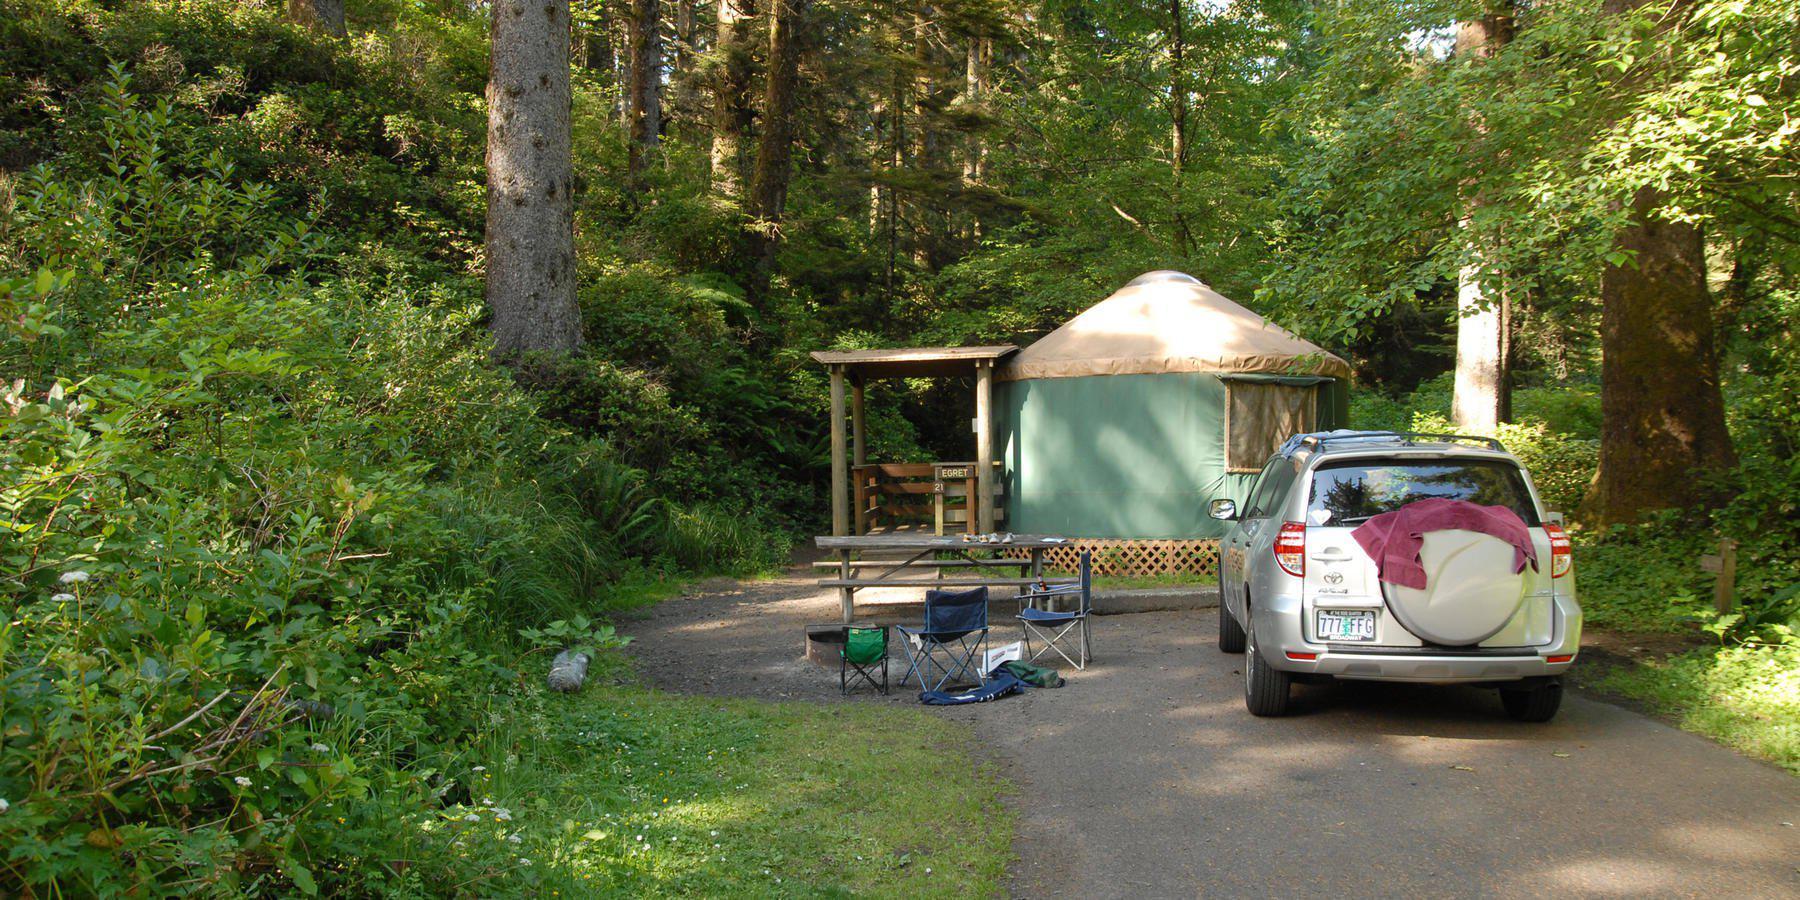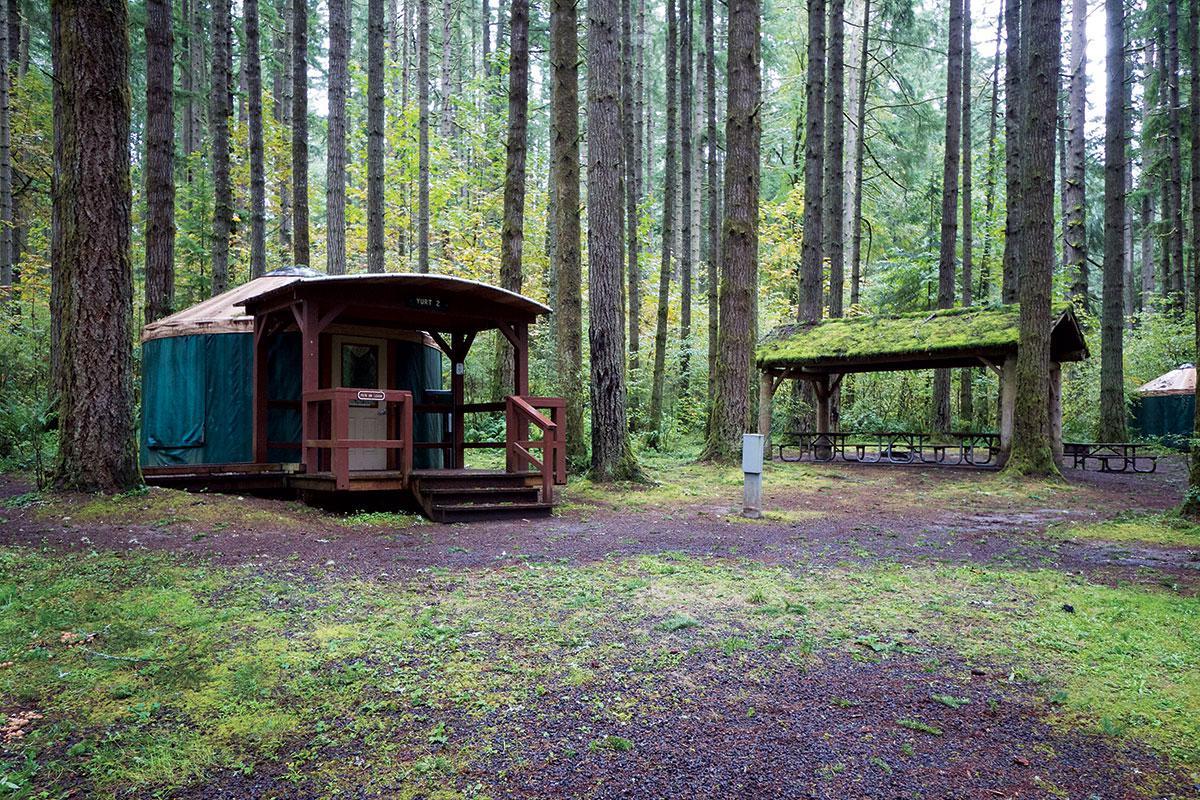The first image is the image on the left, the second image is the image on the right. Considering the images on both sides, is "At least one round house has a wooden porch area with a roof." valid? Answer yes or no. Yes. The first image is the image on the left, the second image is the image on the right. Considering the images on both sides, is "There is a covered wooden structure to the right of the yurt in the image on the right" valid? Answer yes or no. Yes. 